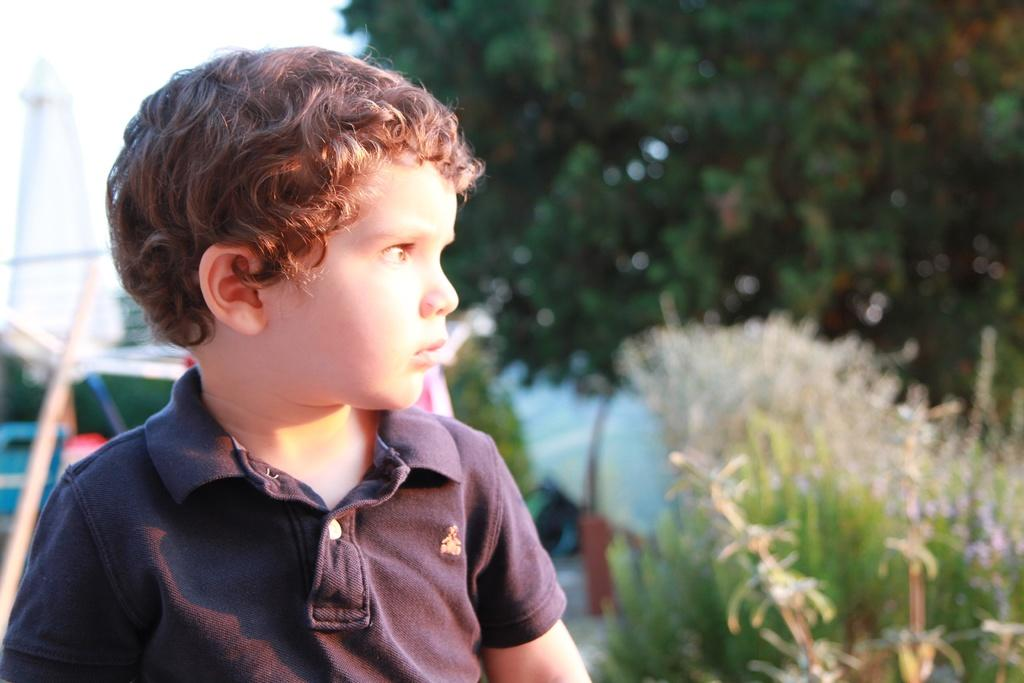What can be seen in the image? There is a person in the image. What is the person wearing? The person is wearing a black shirt. What is visible in the background of the image? There are plants, trees, and the sky visible in the background of the image. What is the color of the sky in the image? The sky appears to be white in color. How many carts are being pushed by the person in the image? There is no cart present in the image; the person is not pushing anything. What is the person's hand doing in the image? The provided facts do not mention the person's hand or its actions, so we cannot answer this question definitively. 